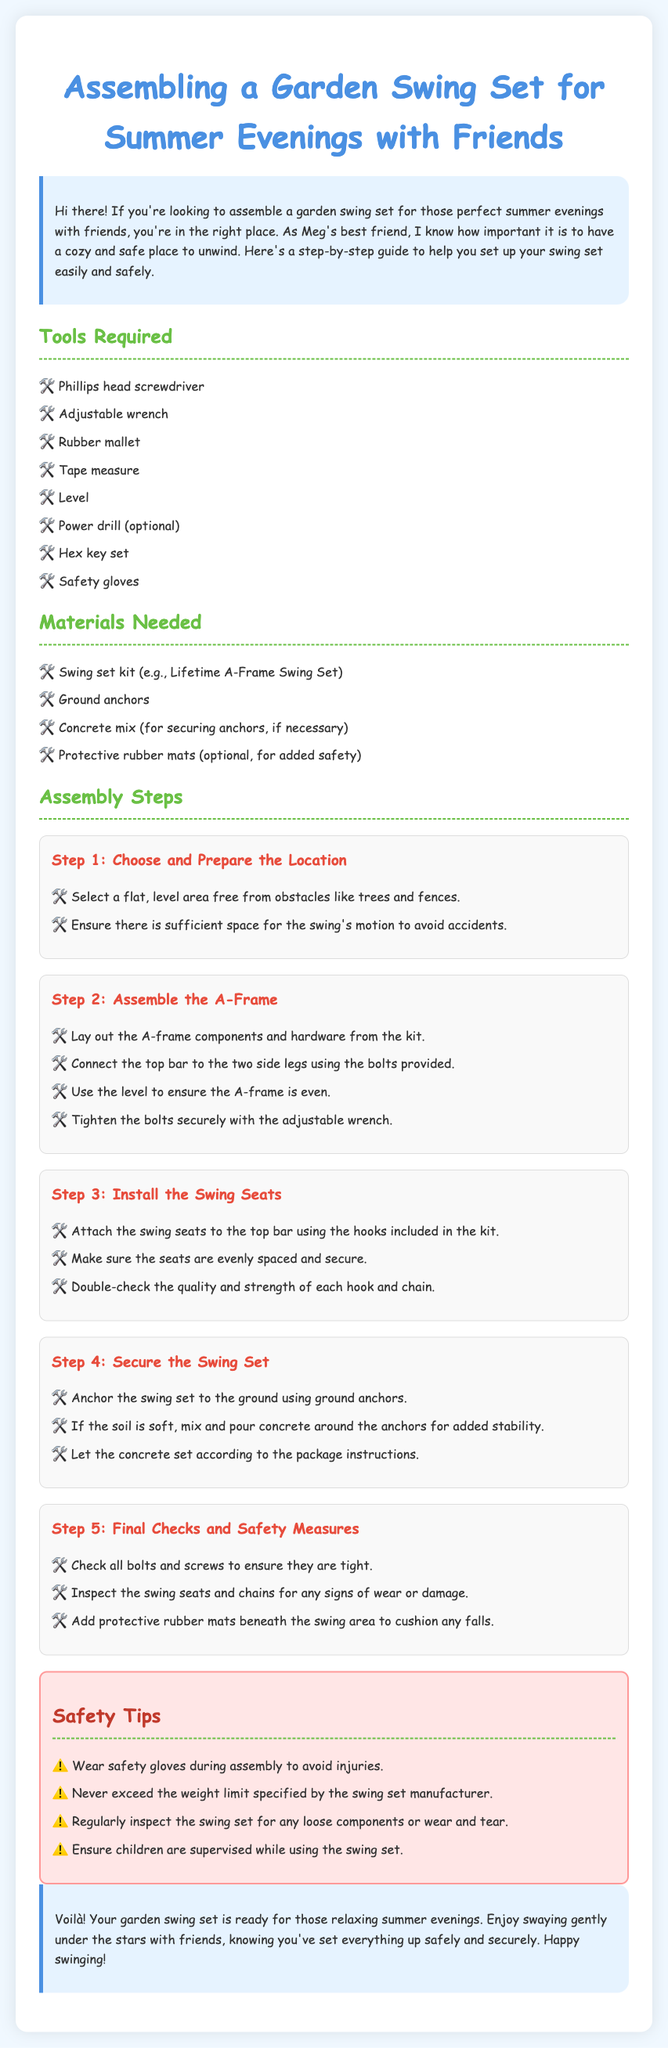What are the tools required? The document lists the tools necessary for assembly under the "Tools Required" section.
Answer: Phillips head screwdriver, Adjustable wrench, Rubber mallet, Tape measure, Level, Power drill (optional), Hex key set, Safety gloves How many steps are there in the assembly process? The document outlines five main steps for assembling the swing set.
Answer: Five What is the first step in the assembly process? The first step is specified as "Choose and Prepare the Location" under the "Assembly Steps" section.
Answer: Choose and Prepare the Location What should be done to secure the swing set? The document indicates that ground anchors should be used to secure the swing set.
Answer: Anchor the swing set to the ground using ground anchors What is a safety tip mentioned in the document? The document provides a list of safety tips, one of which emphasizes wearing safety gloves during assembly.
Answer: Wear safety gloves during assembly Why should children be supervised while using the swing set? The document mentions this as a safety tip to prevent accidents during use.
Answer: To prevent accidents What additional materials might be needed for safety? The document lists protective rubber mats as an optional material for added safety.
Answer: Protective rubber mats Which step involves installing the swing seats? The step that includes this task is explicitly titled "Install the Swing Seats."
Answer: Install the Swing Seats 